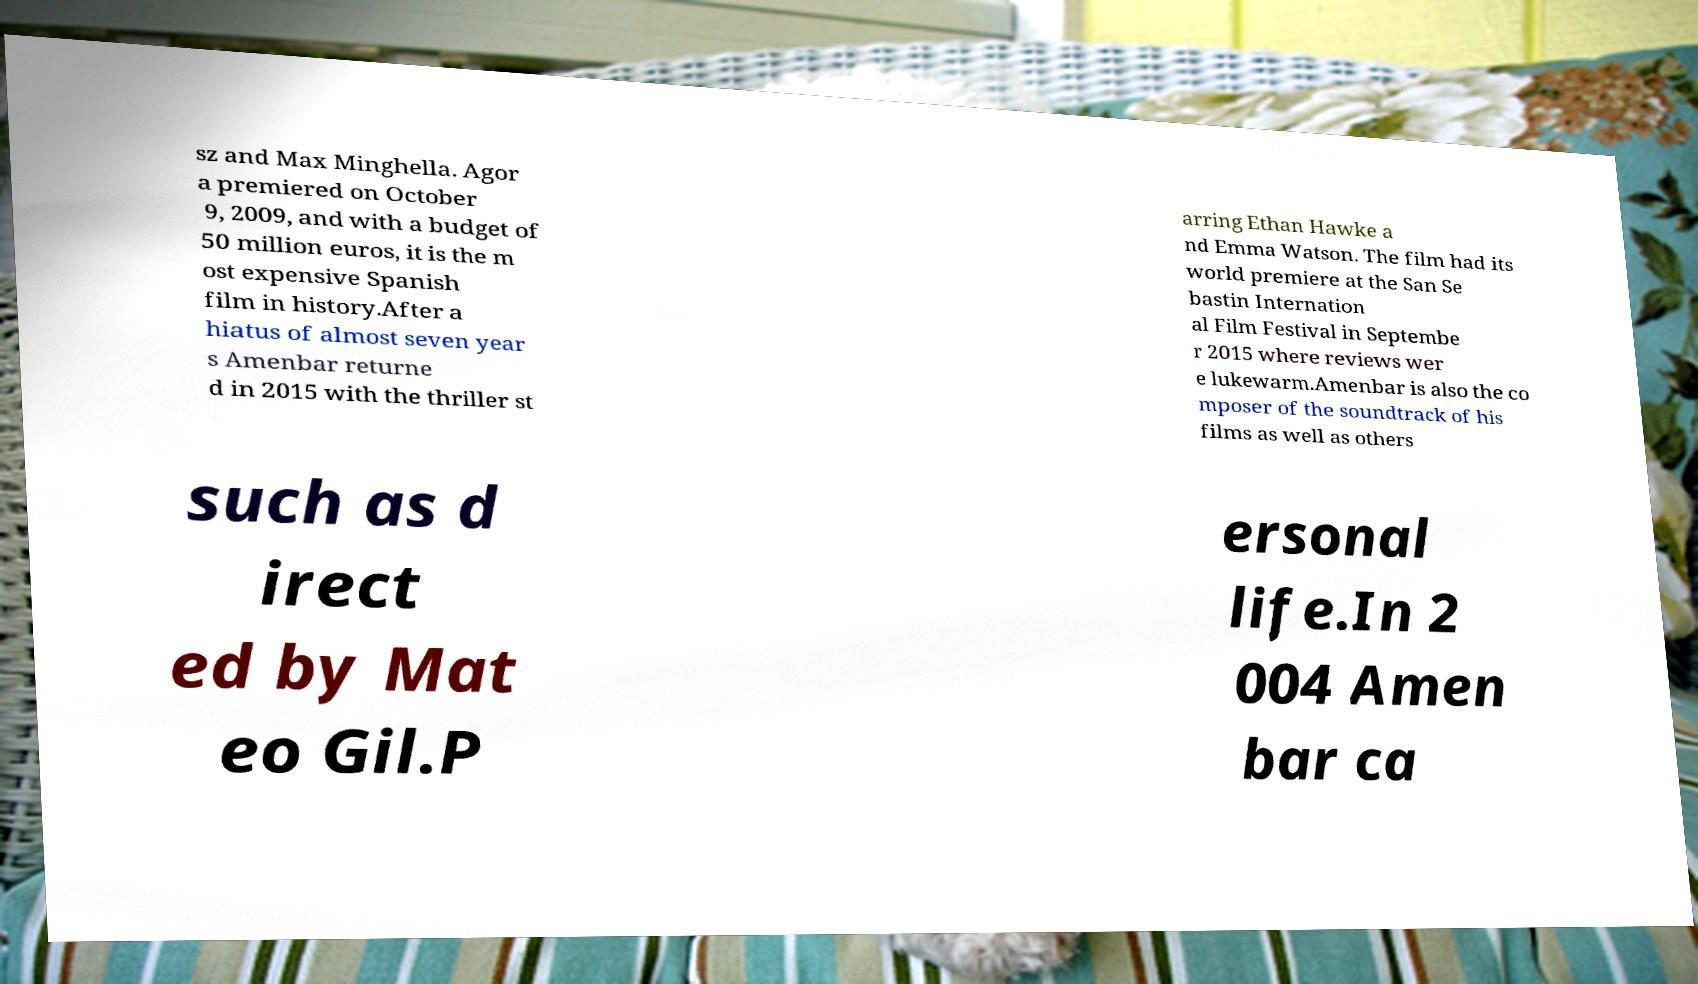Please identify and transcribe the text found in this image. sz and Max Minghella. Agor a premiered on October 9, 2009, and with a budget of 50 million euros, it is the m ost expensive Spanish film in history.After a hiatus of almost seven year s Amenbar returne d in 2015 with the thriller st arring Ethan Hawke a nd Emma Watson. The film had its world premiere at the San Se bastin Internation al Film Festival in Septembe r 2015 where reviews wer e lukewarm.Amenbar is also the co mposer of the soundtrack of his films as well as others such as d irect ed by Mat eo Gil.P ersonal life.In 2 004 Amen bar ca 